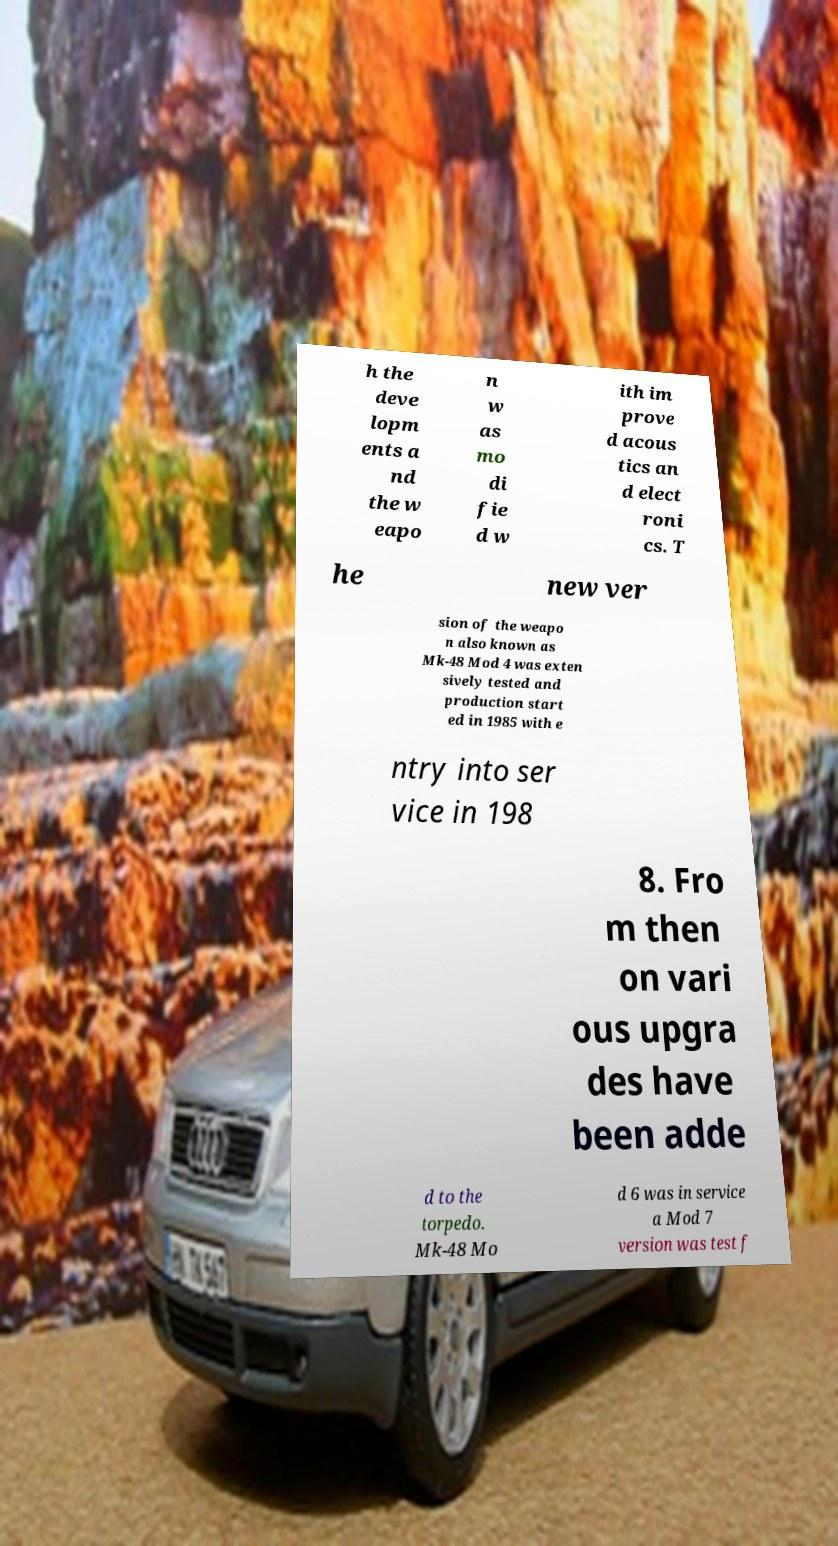For documentation purposes, I need the text within this image transcribed. Could you provide that? h the deve lopm ents a nd the w eapo n w as mo di fie d w ith im prove d acous tics an d elect roni cs. T he new ver sion of the weapo n also known as Mk-48 Mod 4 was exten sively tested and production start ed in 1985 with e ntry into ser vice in 198 8. Fro m then on vari ous upgra des have been adde d to the torpedo. Mk-48 Mo d 6 was in service a Mod 7 version was test f 